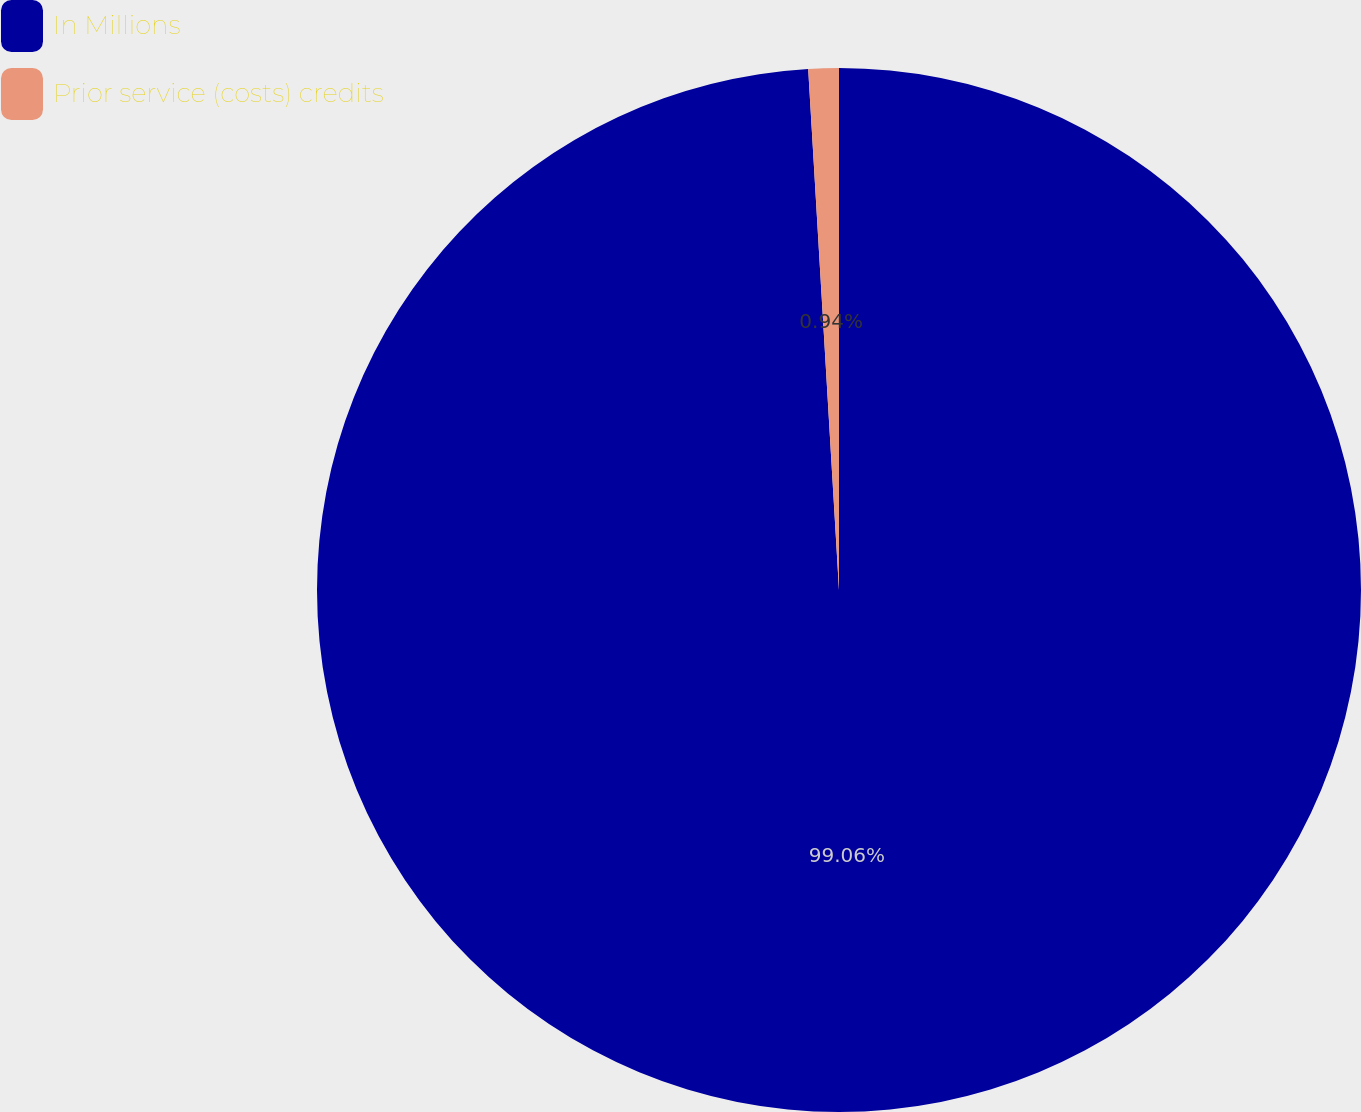Convert chart to OTSL. <chart><loc_0><loc_0><loc_500><loc_500><pie_chart><fcel>In Millions<fcel>Prior service (costs) credits<nl><fcel>99.06%<fcel>0.94%<nl></chart> 